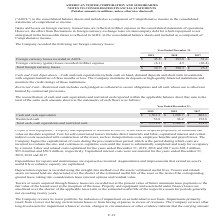According to American Tower Corporation's financial document, What were the Foreign currency losses recorded in AOCL in 2019? According to the financial document, $45.8 (in millions). The relevant text states: "Foreign currency losses recorded in AOCL $ 45.8 $ 385.8 $ 51.6..." Also, What were the Foreign currency (gains) losses recorded in Other expense in 2018? According to the financial document, 4.5 (in millions). The relevant text states: "cy (gains) losses recorded in Other expense (6.1) 4.5 (26.4)..." Also, What does the table show? net foreign currency losses. The document states: "The Company recorded the following net foreign currency losses:..." Also, can you calculate: What was the change in Foreign currency losses recorded in AOCL between 2018 and 2019? Based on the calculation: $45.8-$385.8, the result is -340 (in millions). This is based on the information: "Foreign currency losses recorded in AOCL $ 45.8 $ 385.8 $ 51.6 Foreign currency losses recorded in AOCL $ 45.8 $ 385.8 $ 51.6..." The key data points involved are: 385.8, 45.8. Also, can you calculate: What was the change in Foreign currency (gains) losses recorded in Other expense between 2017 and 2018? Based on the calculation: 4.5-(-26.4), the result is 30.9 (in millions). This is based on the information: "cy (gains) losses recorded in Other expense (6.1) 4.5 (26.4) ains) losses recorded in Other expense (6.1) 4.5 (26.4)..." The key data points involved are: 26.4, 4.5. Also, can you calculate: What was the total percentage change in Total foreign currency losses between 2017 and 2019? To answer this question, I need to perform calculations using the financial data. The calculation is: ($39.7-$25.2)/$25.2, which equals 57.54 (percentage). This is based on the information: "Total foreign currency losses $ 39.7 $ 390.3 $ 25.2 Total foreign currency losses $ 39.7 $ 390.3 $ 25.2..." The key data points involved are: 25.2, 39.7. 